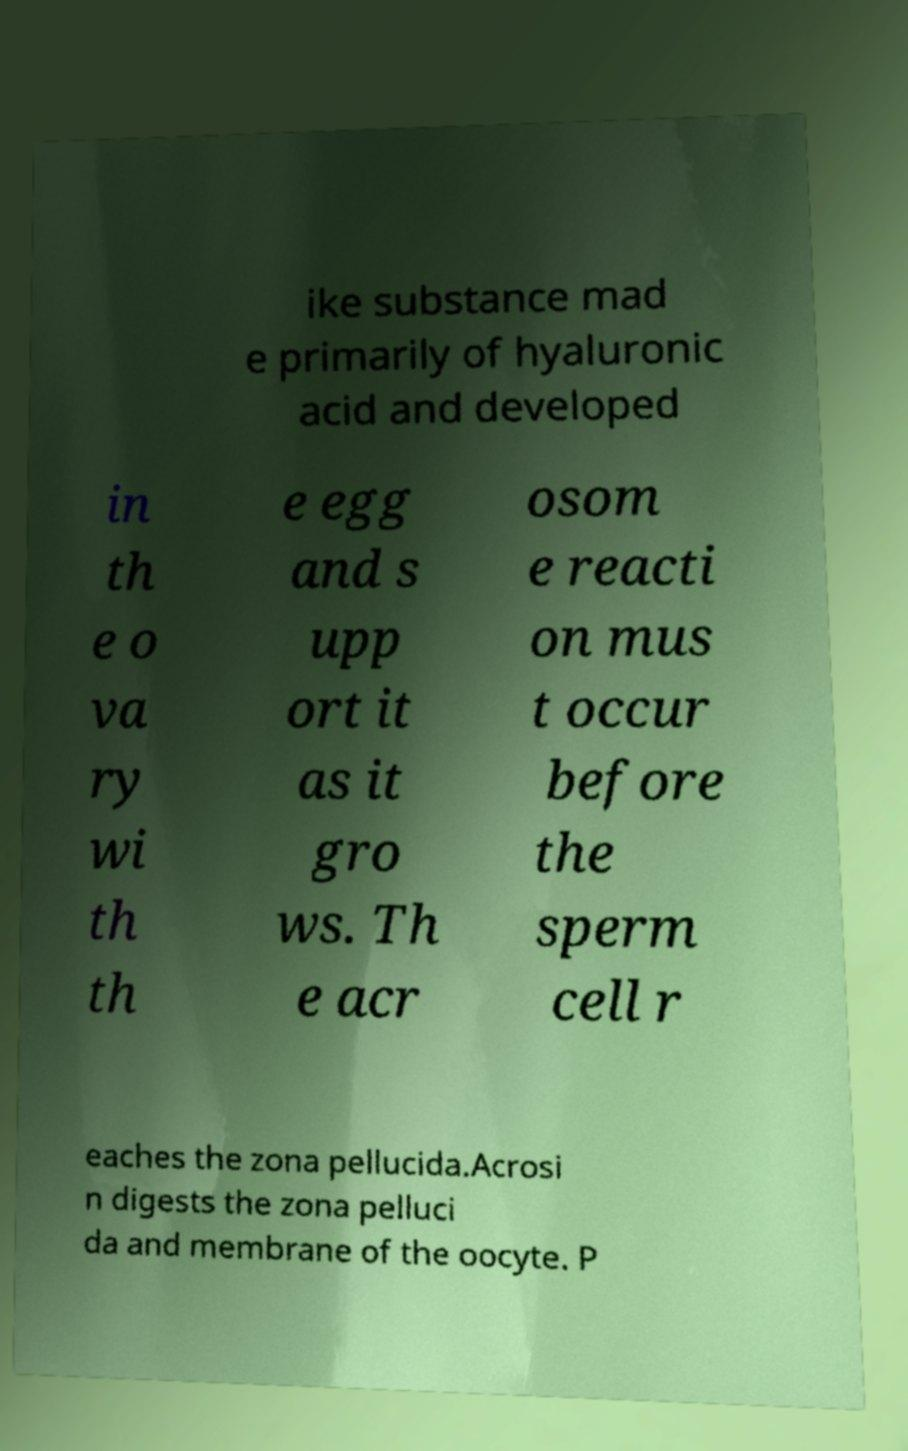What messages or text are displayed in this image? I need them in a readable, typed format. ike substance mad e primarily of hyaluronic acid and developed in th e o va ry wi th th e egg and s upp ort it as it gro ws. Th e acr osom e reacti on mus t occur before the sperm cell r eaches the zona pellucida.Acrosi n digests the zona pelluci da and membrane of the oocyte. P 